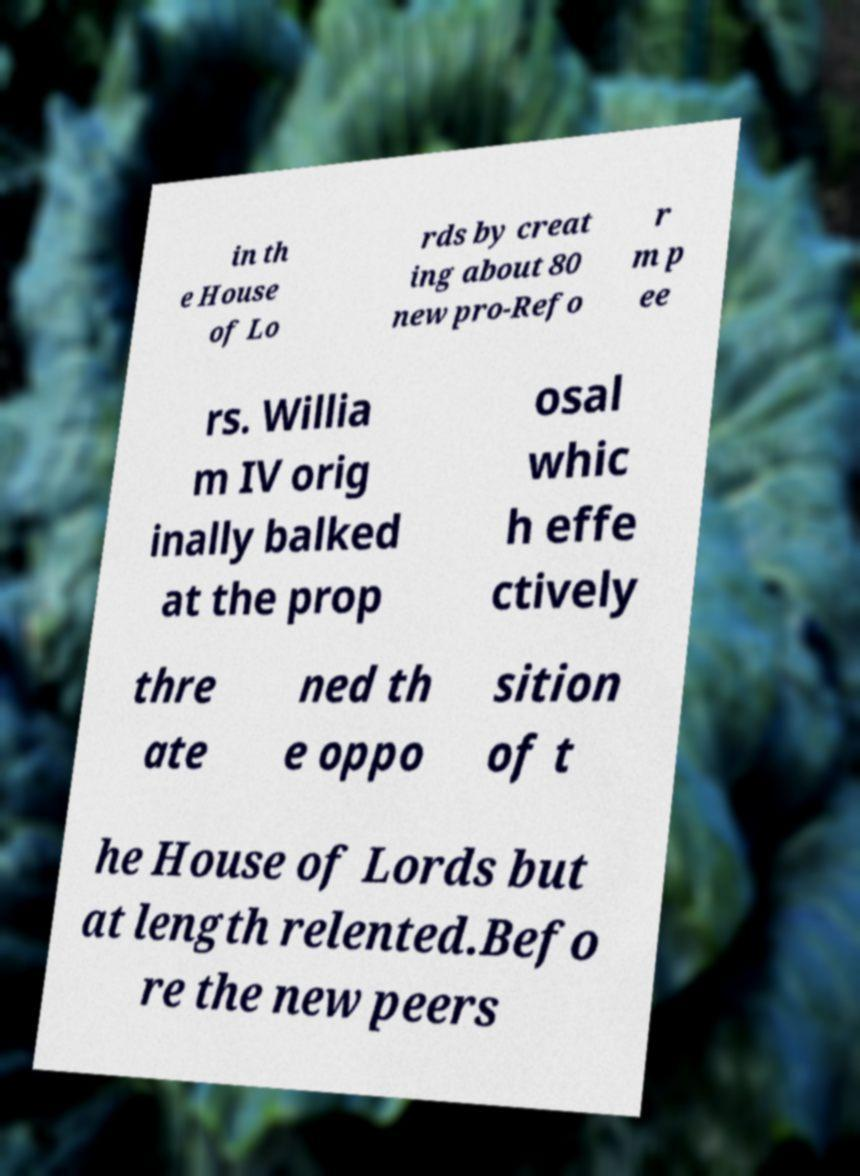Could you extract and type out the text from this image? in th e House of Lo rds by creat ing about 80 new pro-Refo r m p ee rs. Willia m IV orig inally balked at the prop osal whic h effe ctively thre ate ned th e oppo sition of t he House of Lords but at length relented.Befo re the new peers 